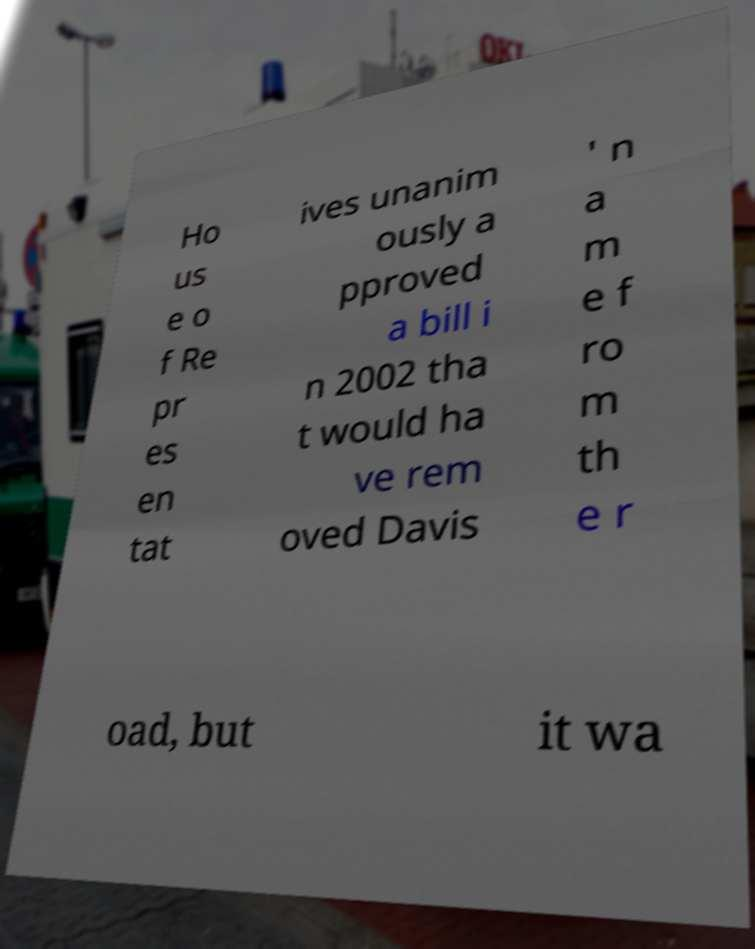Please identify and transcribe the text found in this image. Ho us e o f Re pr es en tat ives unanim ously a pproved a bill i n 2002 tha t would ha ve rem oved Davis ' n a m e f ro m th e r oad, but it wa 